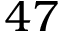Convert formula to latex. <formula><loc_0><loc_0><loc_500><loc_500>4 7</formula> 